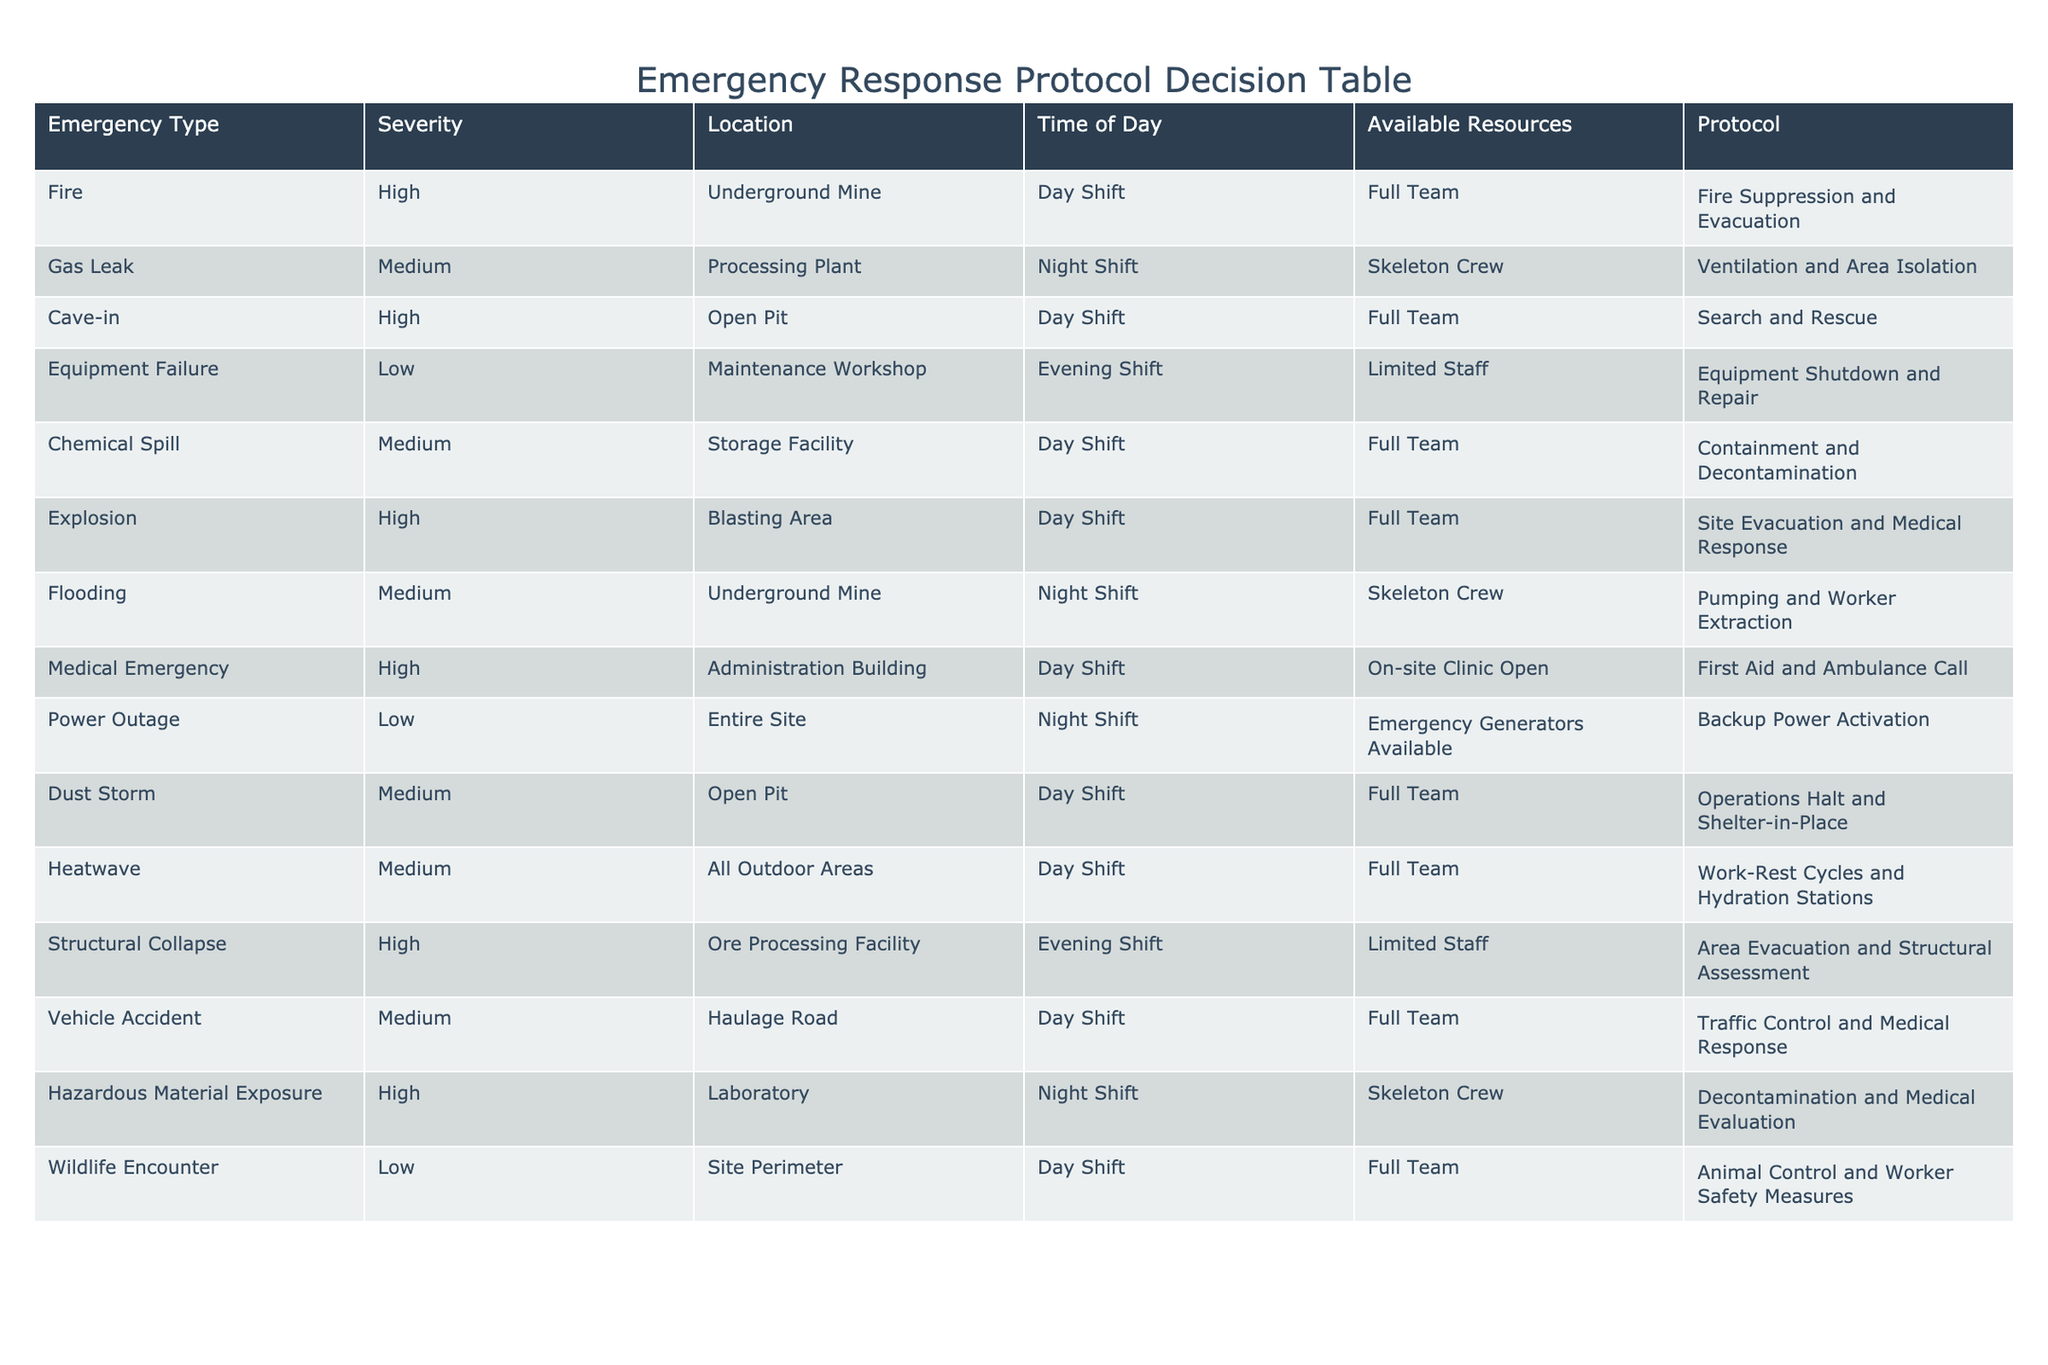What is the response protocol for a fire in the underground mine? According to the table, when there is a fire (Emergency Type) in the underground mine (Location), the response protocol indicated is "Fire Suppression and Evacuation."
Answer: Fire Suppression and Evacuation How many emergency types listed require a full team to respond? By examining the "Available Resources" column for the cases that have "Full Team," we find seven such emergencies: Fire, Cave-in, Chemical Spill, Explosion, Medical Emergency, Dust Storm, and Wildlife Encounter. Thus, there are 7 emergencies.
Answer: 7 Is the protocol for a gas leak the same during day shift and night shift? From the table, we see that during the night shift (when there is a gas leak), the protocol is "Ventilation and Area Isolation," while the table does not list a day shift protocol as a comparison. However, this suggests that they are likely different or have specific considerations based on the staffing level.
Answer: No What is the most severe emergency type during the day shift that has a "Limited Staff" available? We evaluate the "Severity" of emergencies categorized under "Evening Shift" and "Limited Staff." The only one listed is "Structural Collapse," which has a high severity.
Answer: Structural Collapse Which emergency type has the protocol "Pumping and Worker Extraction"? This protocol corresponds to flooding at the underground mine during the night shift, according to the data provided in the table.
Answer: Flooding Are there any emergencies during the day shift that involve chemical exposure? Reviewing the table, we note that there is no specific mention of emergencies involving chemical exposure during the day shift. The only related emergency is a Chemical Spill, which does involve chemicals but does not specify exposure.
Answer: No What is the combined count of low severity emergencies across all locations? By checking the Severity column for "Low," we find that there are three emergencies: Equipment Failure, Power Outage, and Wildlife Encounter. Thus, the combined count is 3.
Answer: 3 What emergency is associated with the highest severity but limited staff during the evening shift? Looking at the evening shift under the "Limited Staff" column for the highest severity, the only record is "Structural Collapse," which is a high-severity emergency.
Answer: Structural Collapse How many emergencies occur at the processing plant? By examining the Location column, we see that there is only one listed emergency at the processing plant, which is a gas leak.
Answer: 1 